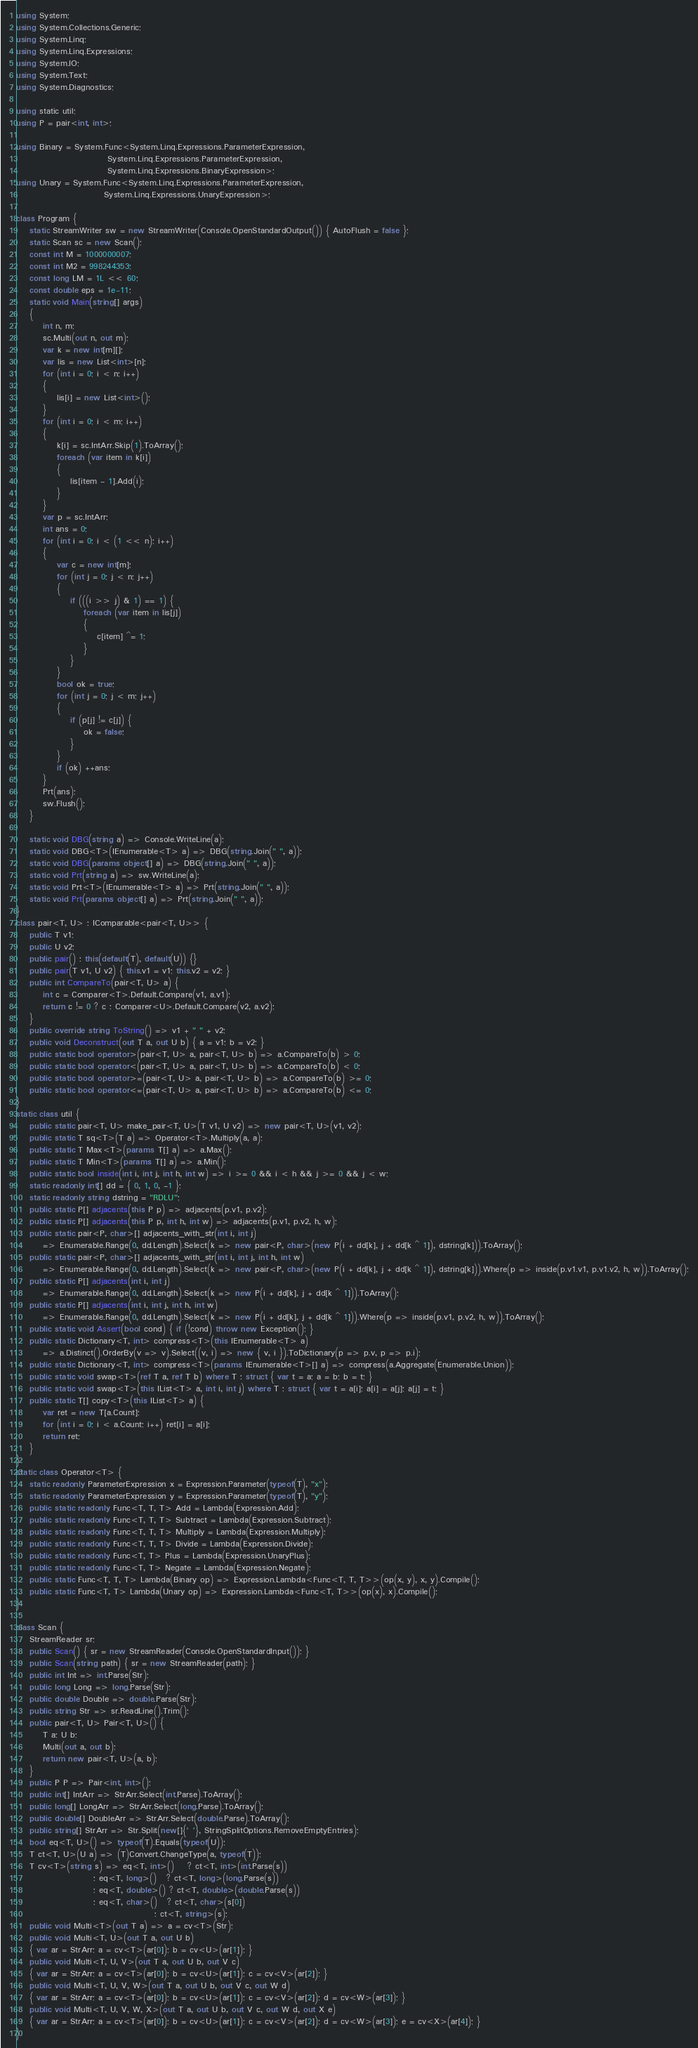<code> <loc_0><loc_0><loc_500><loc_500><_C#_>using System;
using System.Collections.Generic;
using System.Linq;
using System.Linq.Expressions;
using System.IO;
using System.Text;
using System.Diagnostics;

using static util;
using P = pair<int, int>;

using Binary = System.Func<System.Linq.Expressions.ParameterExpression,
                           System.Linq.Expressions.ParameterExpression,
                           System.Linq.Expressions.BinaryExpression>;
using Unary = System.Func<System.Linq.Expressions.ParameterExpression,
                          System.Linq.Expressions.UnaryExpression>;

class Program {
    static StreamWriter sw = new StreamWriter(Console.OpenStandardOutput()) { AutoFlush = false };
    static Scan sc = new Scan();
    const int M = 1000000007;
    const int M2 = 998244353;
    const long LM = 1L << 60;
    const double eps = 1e-11;
    static void Main(string[] args)
    {
        int n, m;
        sc.Multi(out n, out m);
        var k = new int[m][];
        var lis = new List<int>[n];
        for (int i = 0; i < n; i++)
        {
            lis[i] = new List<int>();
        }
        for (int i = 0; i < m; i++)
        {
            k[i] = sc.IntArr.Skip(1).ToArray();
            foreach (var item in k[i])
            {
                lis[item - 1].Add(i);
            }
        }
        var p = sc.IntArr;
        int ans = 0;
        for (int i = 0; i < (1 << n); i++)
        {
            var c = new int[m];
            for (int j = 0; j < n; j++)
            {
                if (((i >> j) & 1) == 1) {
                    foreach (var item in lis[j])
                    {
                        c[item] ^= 1;
                    }
                }
            }
            bool ok = true;
            for (int j = 0; j < m; j++)
            {
                if (p[j] != c[j]) {
                    ok = false;
                }
            }
            if (ok) ++ans;
        }
        Prt(ans);
        sw.Flush();
    }

    static void DBG(string a) => Console.WriteLine(a);
    static void DBG<T>(IEnumerable<T> a) => DBG(string.Join(" ", a));
    static void DBG(params object[] a) => DBG(string.Join(" ", a));
    static void Prt(string a) => sw.WriteLine(a);
    static void Prt<T>(IEnumerable<T> a) => Prt(string.Join(" ", a));
    static void Prt(params object[] a) => Prt(string.Join(" ", a));
}
class pair<T, U> : IComparable<pair<T, U>> {
    public T v1;
    public U v2;
    public pair() : this(default(T), default(U)) {}
    public pair(T v1, U v2) { this.v1 = v1; this.v2 = v2; }
    public int CompareTo(pair<T, U> a) {
        int c = Comparer<T>.Default.Compare(v1, a.v1);
        return c != 0 ? c : Comparer<U>.Default.Compare(v2, a.v2);
    }
    public override string ToString() => v1 + " " + v2;
    public void Deconstruct(out T a, out U b) { a = v1; b = v2; }
    public static bool operator>(pair<T, U> a, pair<T, U> b) => a.CompareTo(b) > 0;
    public static bool operator<(pair<T, U> a, pair<T, U> b) => a.CompareTo(b) < 0;
    public static bool operator>=(pair<T, U> a, pair<T, U> b) => a.CompareTo(b) >= 0;
    public static bool operator<=(pair<T, U> a, pair<T, U> b) => a.CompareTo(b) <= 0;
}
static class util {
    public static pair<T, U> make_pair<T, U>(T v1, U v2) => new pair<T, U>(v1, v2);
    public static T sq<T>(T a) => Operator<T>.Multiply(a, a);
    public static T Max<T>(params T[] a) => a.Max();
    public static T Min<T>(params T[] a) => a.Min();
    public static bool inside(int i, int j, int h, int w) => i >= 0 && i < h && j >= 0 && j < w;
    static readonly int[] dd = { 0, 1, 0, -1 };
    static readonly string dstring = "RDLU";
    public static P[] adjacents(this P p) => adjacents(p.v1, p.v2);
    public static P[] adjacents(this P p, int h, int w) => adjacents(p.v1, p.v2, h, w);
    public static pair<P, char>[] adjacents_with_str(int i, int j)
        => Enumerable.Range(0, dd.Length).Select(k => new pair<P, char>(new P(i + dd[k], j + dd[k ^ 1]), dstring[k])).ToArray();
    public static pair<P, char>[] adjacents_with_str(int i, int j, int h, int w)
        => Enumerable.Range(0, dd.Length).Select(k => new pair<P, char>(new P(i + dd[k], j + dd[k ^ 1]), dstring[k])).Where(p => inside(p.v1.v1, p.v1.v2, h, w)).ToArray();
    public static P[] adjacents(int i, int j)
        => Enumerable.Range(0, dd.Length).Select(k => new P(i + dd[k], j + dd[k ^ 1])).ToArray();
    public static P[] adjacents(int i, int j, int h, int w)
        => Enumerable.Range(0, dd.Length).Select(k => new P(i + dd[k], j + dd[k ^ 1])).Where(p => inside(p.v1, p.v2, h, w)).ToArray();
    public static void Assert(bool cond) { if (!cond) throw new Exception(); }
    public static Dictionary<T, int> compress<T>(this IEnumerable<T> a)
        => a.Distinct().OrderBy(v => v).Select((v, i) => new { v, i }).ToDictionary(p => p.v, p => p.i);
    public static Dictionary<T, int> compress<T>(params IEnumerable<T>[] a) => compress(a.Aggregate(Enumerable.Union));
    public static void swap<T>(ref T a, ref T b) where T : struct { var t = a; a = b; b = t; }
    public static void swap<T>(this IList<T> a, int i, int j) where T : struct { var t = a[i]; a[i] = a[j]; a[j] = t; }
    public static T[] copy<T>(this IList<T> a) {
        var ret = new T[a.Count];
        for (int i = 0; i < a.Count; i++) ret[i] = a[i];
        return ret;
    }
}
static class Operator<T> {
    static readonly ParameterExpression x = Expression.Parameter(typeof(T), "x");
    static readonly ParameterExpression y = Expression.Parameter(typeof(T), "y");
    public static readonly Func<T, T, T> Add = Lambda(Expression.Add);
    public static readonly Func<T, T, T> Subtract = Lambda(Expression.Subtract);
    public static readonly Func<T, T, T> Multiply = Lambda(Expression.Multiply);
    public static readonly Func<T, T, T> Divide = Lambda(Expression.Divide);
    public static readonly Func<T, T> Plus = Lambda(Expression.UnaryPlus);
    public static readonly Func<T, T> Negate = Lambda(Expression.Negate);
    public static Func<T, T, T> Lambda(Binary op) => Expression.Lambda<Func<T, T, T>>(op(x, y), x, y).Compile();
    public static Func<T, T> Lambda(Unary op) => Expression.Lambda<Func<T, T>>(op(x), x).Compile();
}

class Scan {
    StreamReader sr;
    public Scan() { sr = new StreamReader(Console.OpenStandardInput()); }
    public Scan(string path) { sr = new StreamReader(path); }
    public int Int => int.Parse(Str);
    public long Long => long.Parse(Str);
    public double Double => double.Parse(Str);
    public string Str => sr.ReadLine().Trim();
    public pair<T, U> Pair<T, U>() {
        T a; U b;
        Multi(out a, out b);
        return new pair<T, U>(a, b);
    }
    public P P => Pair<int, int>();
    public int[] IntArr => StrArr.Select(int.Parse).ToArray();
    public long[] LongArr => StrArr.Select(long.Parse).ToArray();
    public double[] DoubleArr => StrArr.Select(double.Parse).ToArray();
    public string[] StrArr => Str.Split(new[]{' '}, StringSplitOptions.RemoveEmptyEntries);
    bool eq<T, U>() => typeof(T).Equals(typeof(U));
    T ct<T, U>(U a) => (T)Convert.ChangeType(a, typeof(T));
    T cv<T>(string s) => eq<T, int>()    ? ct<T, int>(int.Parse(s))
                       : eq<T, long>()   ? ct<T, long>(long.Parse(s))
                       : eq<T, double>() ? ct<T, double>(double.Parse(s))
                       : eq<T, char>()   ? ct<T, char>(s[0])
                                         : ct<T, string>(s);
    public void Multi<T>(out T a) => a = cv<T>(Str);
    public void Multi<T, U>(out T a, out U b)
    { var ar = StrArr; a = cv<T>(ar[0]); b = cv<U>(ar[1]); }
    public void Multi<T, U, V>(out T a, out U b, out V c)
    { var ar = StrArr; a = cv<T>(ar[0]); b = cv<U>(ar[1]); c = cv<V>(ar[2]); }
    public void Multi<T, U, V, W>(out T a, out U b, out V c, out W d)
    { var ar = StrArr; a = cv<T>(ar[0]); b = cv<U>(ar[1]); c = cv<V>(ar[2]); d = cv<W>(ar[3]); }
    public void Multi<T, U, V, W, X>(out T a, out U b, out V c, out W d, out X e)
    { var ar = StrArr; a = cv<T>(ar[0]); b = cv<U>(ar[1]); c = cv<V>(ar[2]); d = cv<W>(ar[3]); e = cv<X>(ar[4]); }
}
</code> 